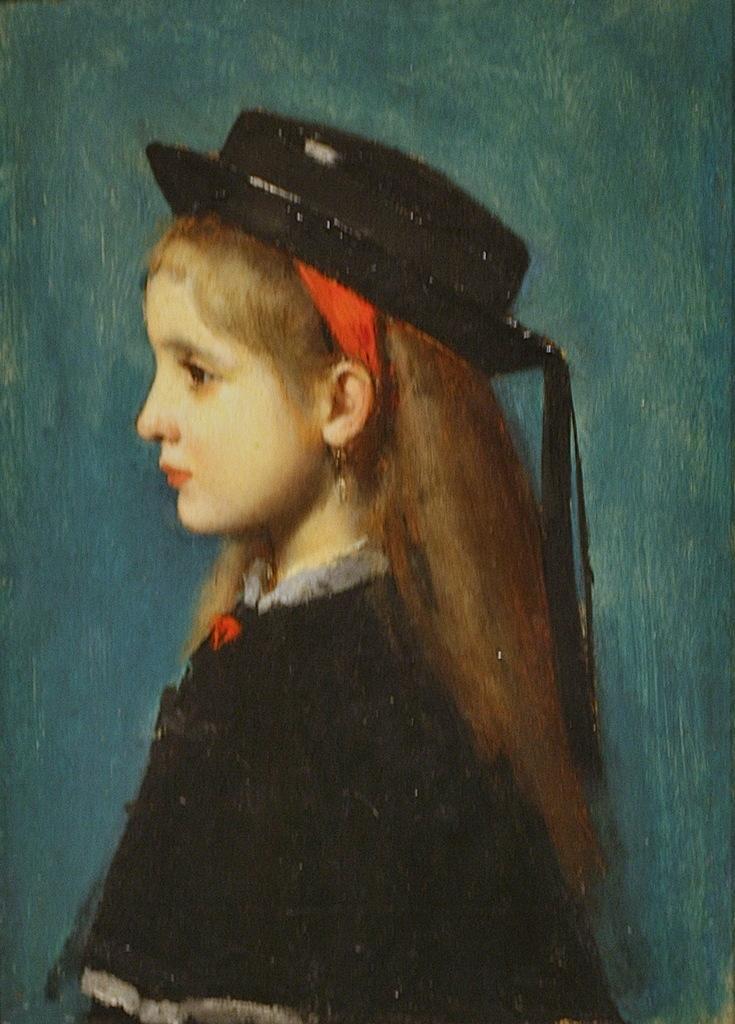Could you give a brief overview of what you see in this image? In this image I can see the person and the person is wearing black color dress and black color cap and the background is in green color. 